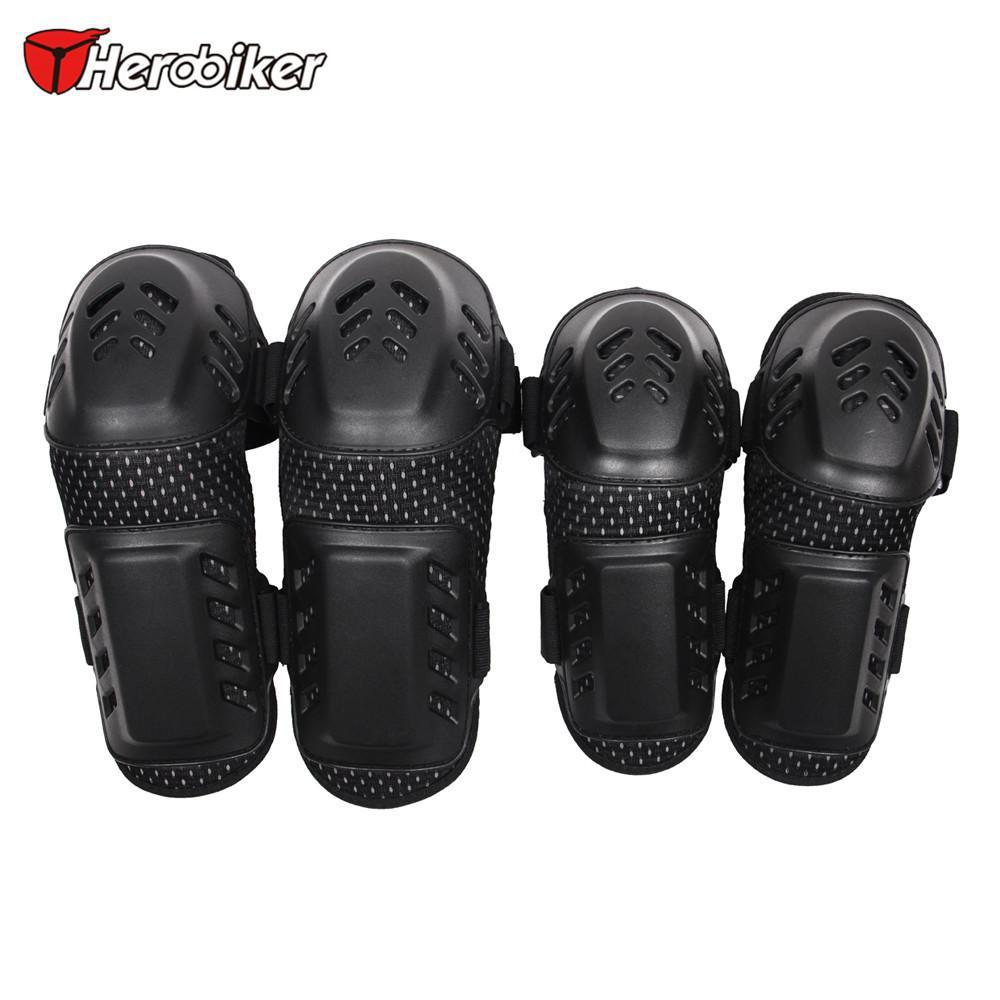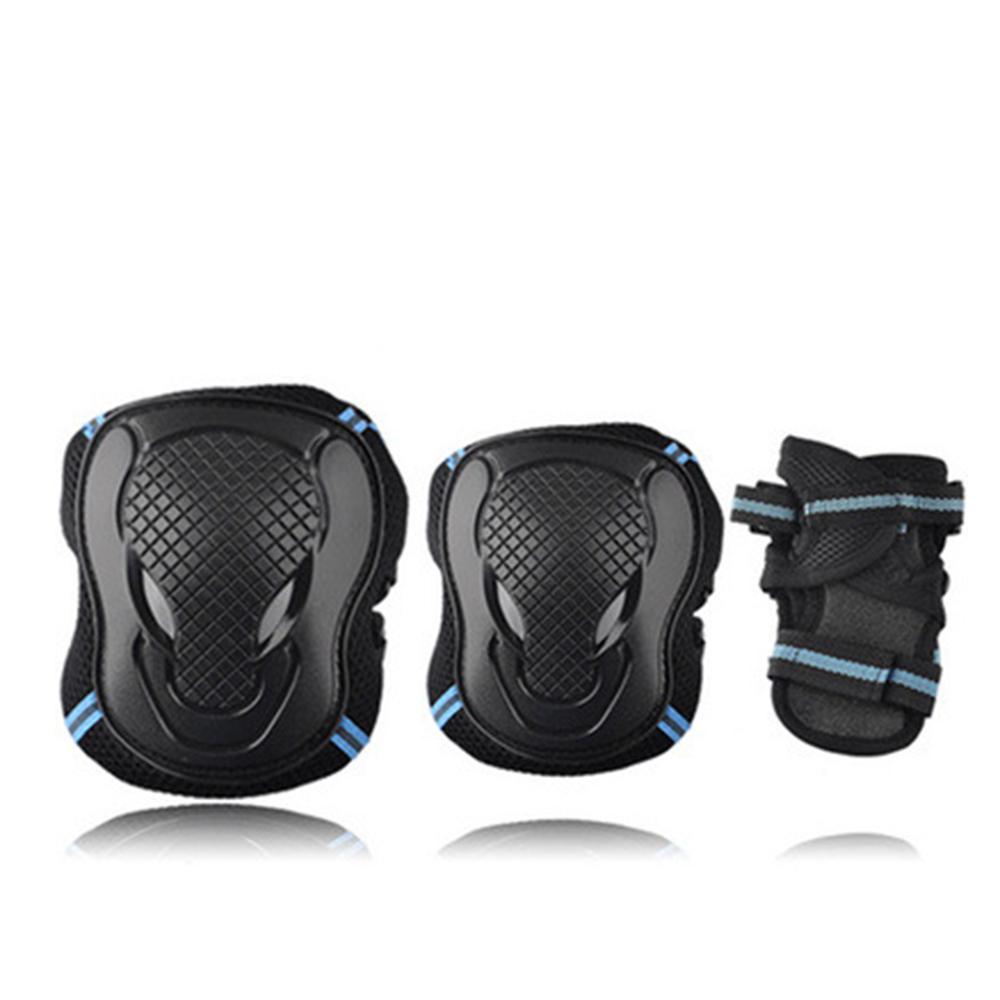The first image is the image on the left, the second image is the image on the right. Assess this claim about the two images: "One image shows more than three individual items of protective gear.". Correct or not? Answer yes or no. Yes. The first image is the image on the left, the second image is the image on the right. Considering the images on both sides, is "There are at least two sets of pads in the left image." valid? Answer yes or no. Yes. 